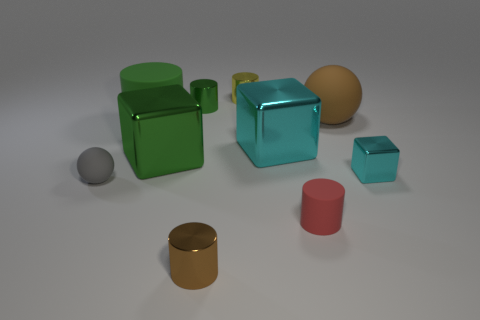What number of small shiny cylinders are behind the brown shiny object and in front of the tiny yellow metal cylinder?
Make the answer very short. 1. What number of objects are blocks that are on the right side of the red rubber cylinder or balls that are to the right of the tiny green cylinder?
Make the answer very short. 2. What number of other objects are the same size as the brown cylinder?
Your answer should be compact. 5. What shape is the green shiny thing that is behind the big metallic block that is on the right side of the green metal cylinder?
Make the answer very short. Cylinder. There is a cube left of the tiny yellow metal cylinder; is it the same color as the metal cube that is to the right of the tiny red matte thing?
Provide a short and direct response. No. Is there anything else that is the same color as the tiny sphere?
Your answer should be compact. No. The tiny rubber cylinder has what color?
Offer a very short reply. Red. Is there a small green matte sphere?
Offer a very short reply. No. There is a gray matte thing; are there any green rubber things in front of it?
Your answer should be very brief. No. There is a green object that is the same shape as the small cyan thing; what is it made of?
Ensure brevity in your answer.  Metal. 